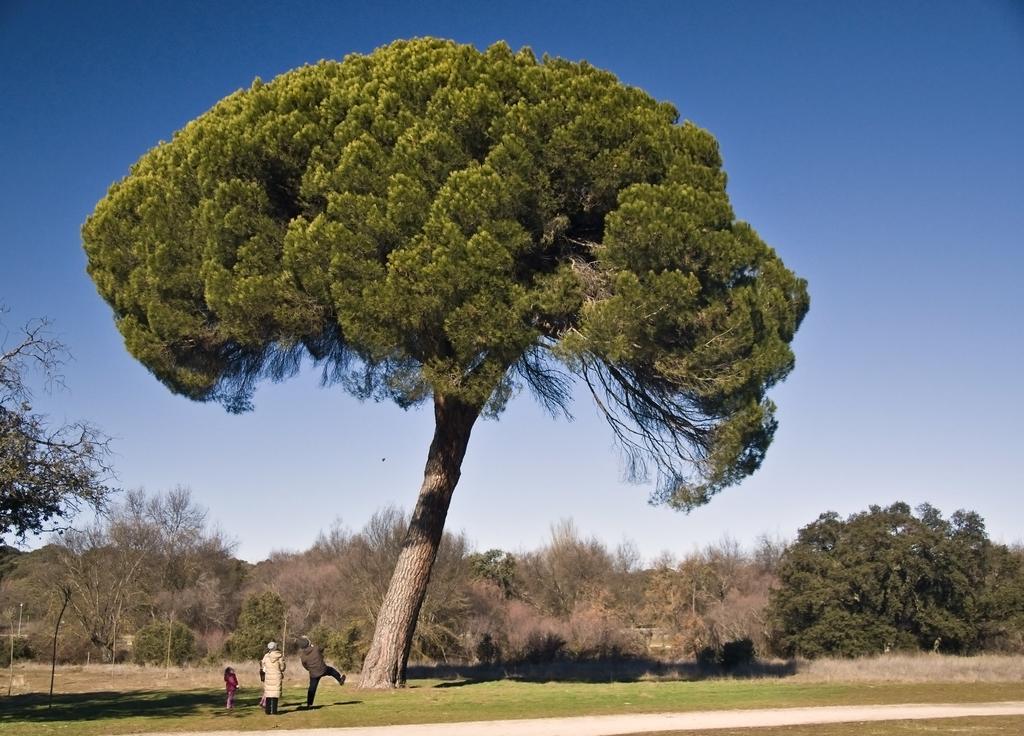How would you summarize this image in a sentence or two? Here we can see two kids and a person standing on the ground and next to them there is a person in motion on the ground. In the background there are trees,grass and sky. 